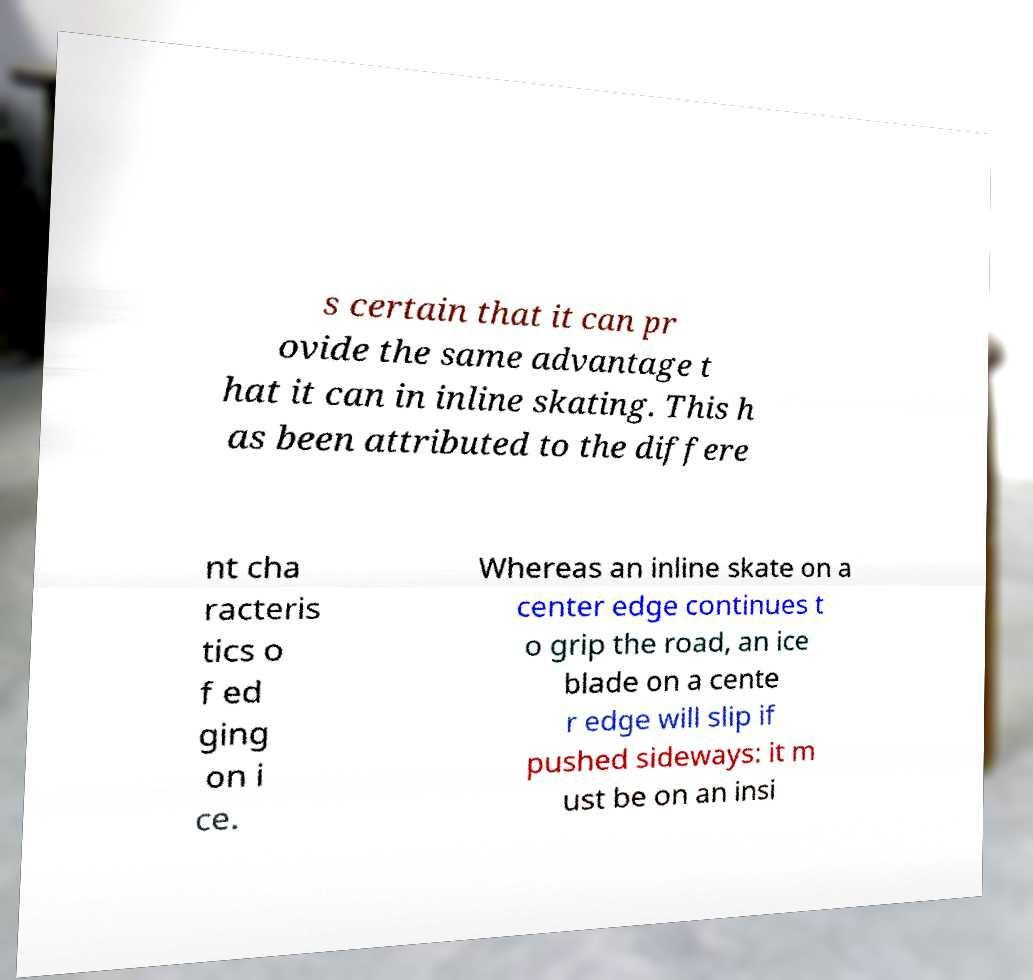Could you extract and type out the text from this image? s certain that it can pr ovide the same advantage t hat it can in inline skating. This h as been attributed to the differe nt cha racteris tics o f ed ging on i ce. Whereas an inline skate on a center edge continues t o grip the road, an ice blade on a cente r edge will slip if pushed sideways: it m ust be on an insi 